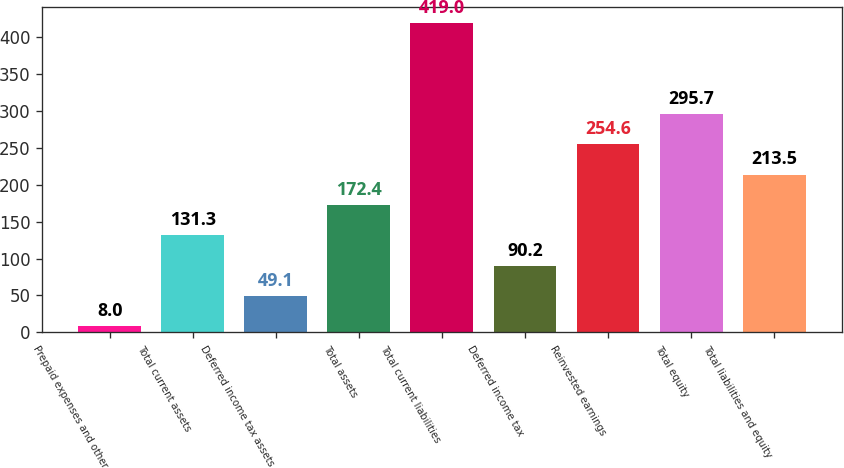Convert chart to OTSL. <chart><loc_0><loc_0><loc_500><loc_500><bar_chart><fcel>Prepaid expenses and other<fcel>Total current assets<fcel>Deferred income tax assets<fcel>Total assets<fcel>Total current liabilities<fcel>Deferred income tax<fcel>Reinvested earnings<fcel>Total equity<fcel>Total liabilities and equity<nl><fcel>8<fcel>131.3<fcel>49.1<fcel>172.4<fcel>419<fcel>90.2<fcel>254.6<fcel>295.7<fcel>213.5<nl></chart> 